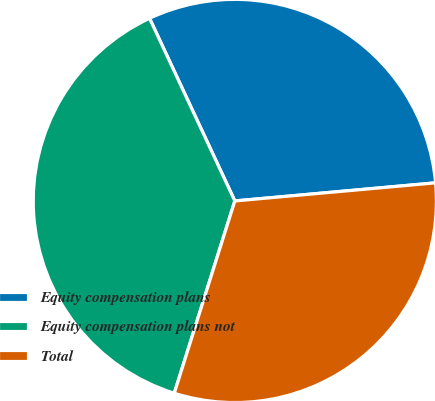Convert chart. <chart><loc_0><loc_0><loc_500><loc_500><pie_chart><fcel>Equity compensation plans<fcel>Equity compensation plans not<fcel>Total<nl><fcel>30.52%<fcel>38.19%<fcel>31.29%<nl></chart> 